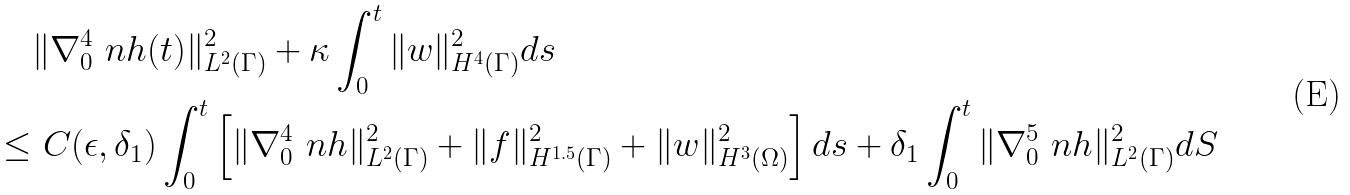Convert formula to latex. <formula><loc_0><loc_0><loc_500><loc_500>& \| \nabla _ { 0 } ^ { 4 } \ n h ( t ) \| ^ { 2 } _ { L ^ { 2 } ( \Gamma ) } + \kappa \int _ { 0 } ^ { t } \| w \| ^ { 2 } _ { H ^ { 4 } ( \Gamma ) } d s \\ \leq & \ C ( \epsilon , \delta _ { 1 } ) \int _ { 0 } ^ { t } \left [ \| \nabla _ { 0 } ^ { 4 } \ n h \| ^ { 2 } _ { L ^ { 2 } ( \Gamma ) } + \| f \| ^ { 2 } _ { H ^ { 1 . 5 } ( \Gamma ) } + \| w \| ^ { 2 } _ { H ^ { 3 } ( \Omega ) } \right ] d s + \delta _ { 1 } \int _ { 0 } ^ { t } \| \nabla _ { 0 } ^ { 5 } \ n h \| ^ { 2 } _ { L ^ { 2 } ( \Gamma ) } d S</formula> 